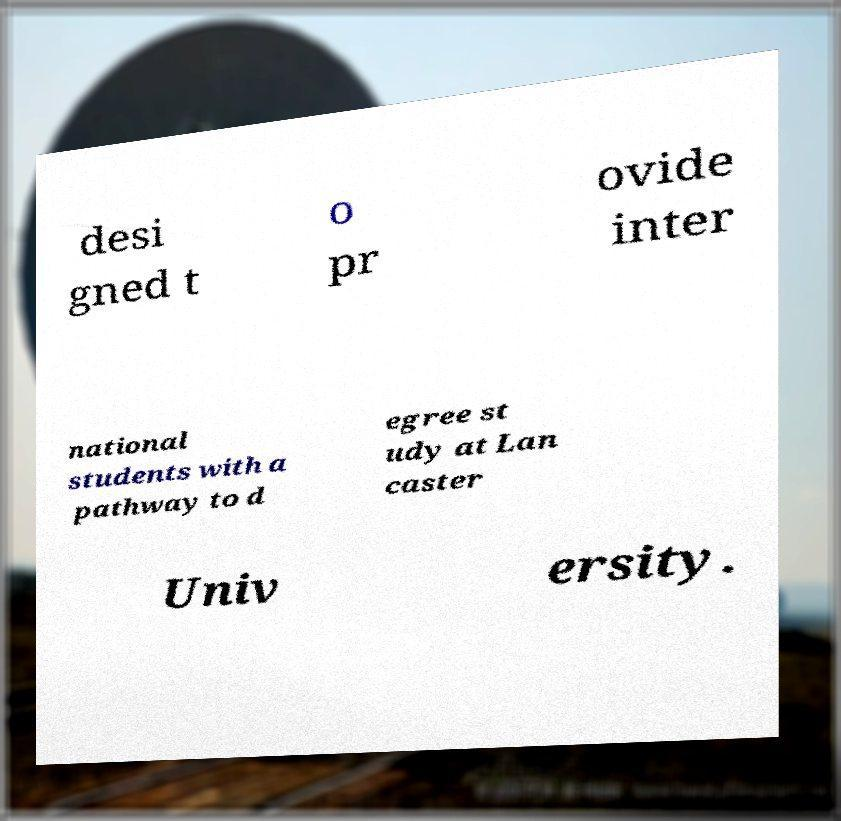Could you assist in decoding the text presented in this image and type it out clearly? desi gned t o pr ovide inter national students with a pathway to d egree st udy at Lan caster Univ ersity. 